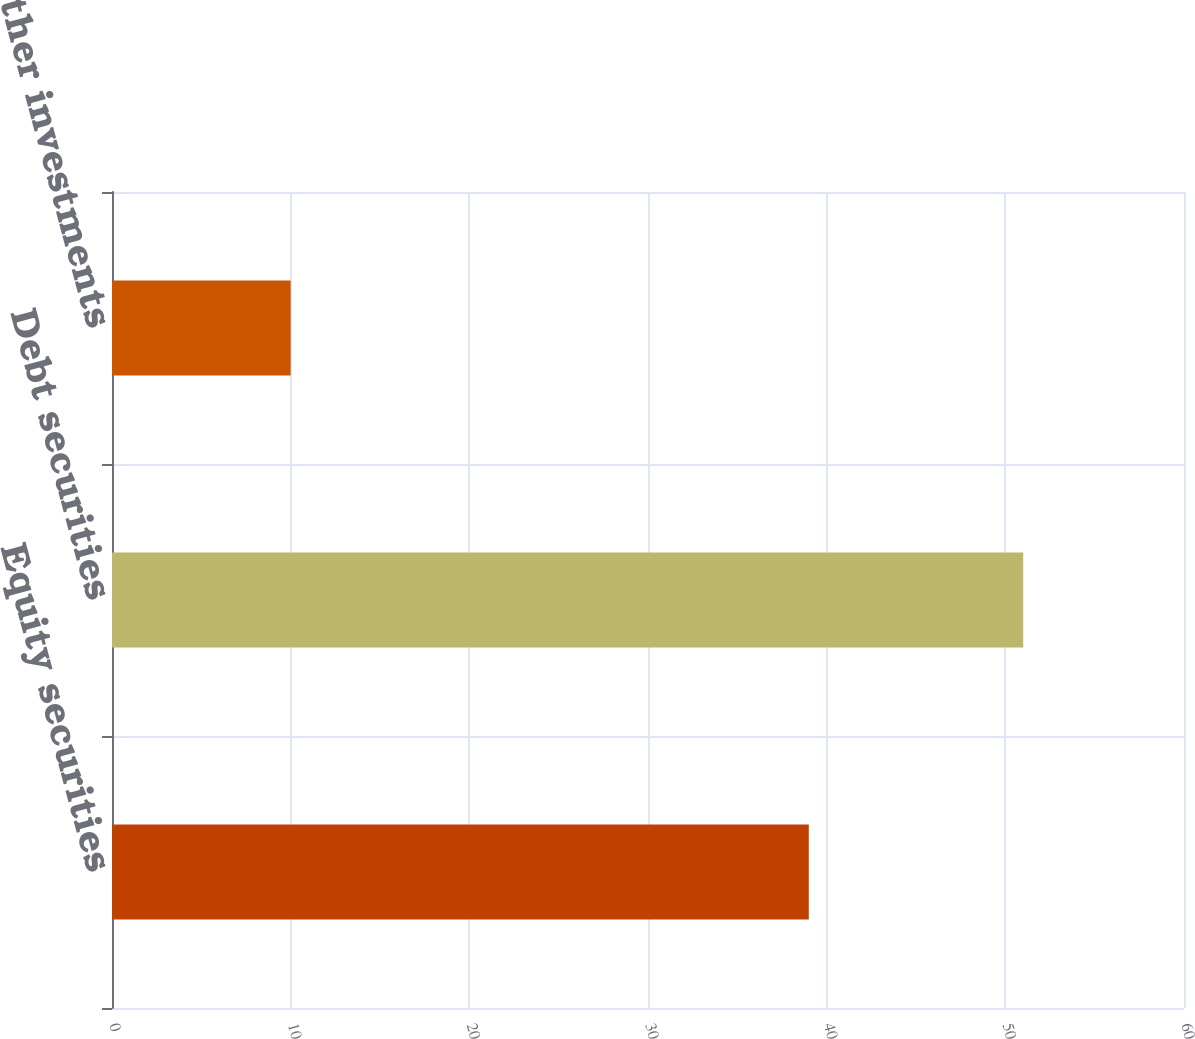Convert chart to OTSL. <chart><loc_0><loc_0><loc_500><loc_500><bar_chart><fcel>Equity securities<fcel>Debt securities<fcel>Other investments<nl><fcel>39<fcel>51<fcel>10<nl></chart> 